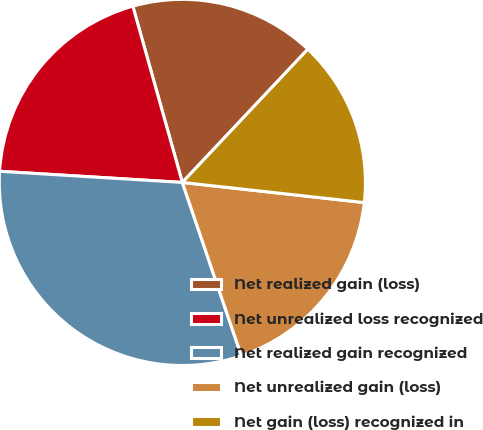Convert chart to OTSL. <chart><loc_0><loc_0><loc_500><loc_500><pie_chart><fcel>Net realized gain (loss)<fcel>Net unrealized loss recognized<fcel>Net realized gain recognized<fcel>Net unrealized gain (loss)<fcel>Net gain (loss) recognized in<nl><fcel>16.38%<fcel>19.67%<fcel>31.19%<fcel>18.02%<fcel>14.73%<nl></chart> 